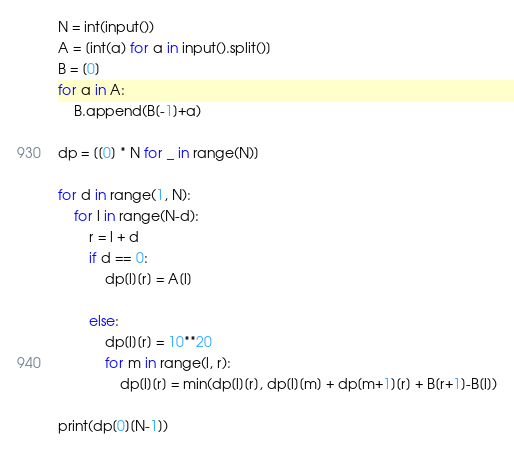Convert code to text. <code><loc_0><loc_0><loc_500><loc_500><_Python_>N = int(input())
A = [int(a) for a in input().split()]
B = [0]
for a in A:
    B.append(B[-1]+a)

dp = [[0] * N for _ in range(N)]

for d in range(1, N):
    for l in range(N-d):
        r = l + d
        if d == 0:
            dp[l][r] = A[l]
            
        else:
            dp[l][r] = 10**20
            for m in range(l, r):
                dp[l][r] = min(dp[l][r], dp[l][m] + dp[m+1][r] + B[r+1]-B[l])
    
print(dp[0][N-1])</code> 